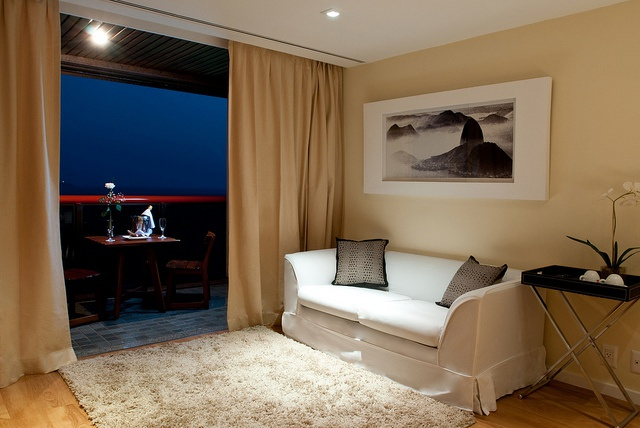Describe the objects in this image and their specific colors. I can see couch in maroon, gray, lightgray, and darkgray tones, chair in maroon, black, and darkblue tones, chair in black and maroon tones, dining table in maroon, black, and brown tones, and potted plant in maroon, black, olive, and gray tones in this image. 